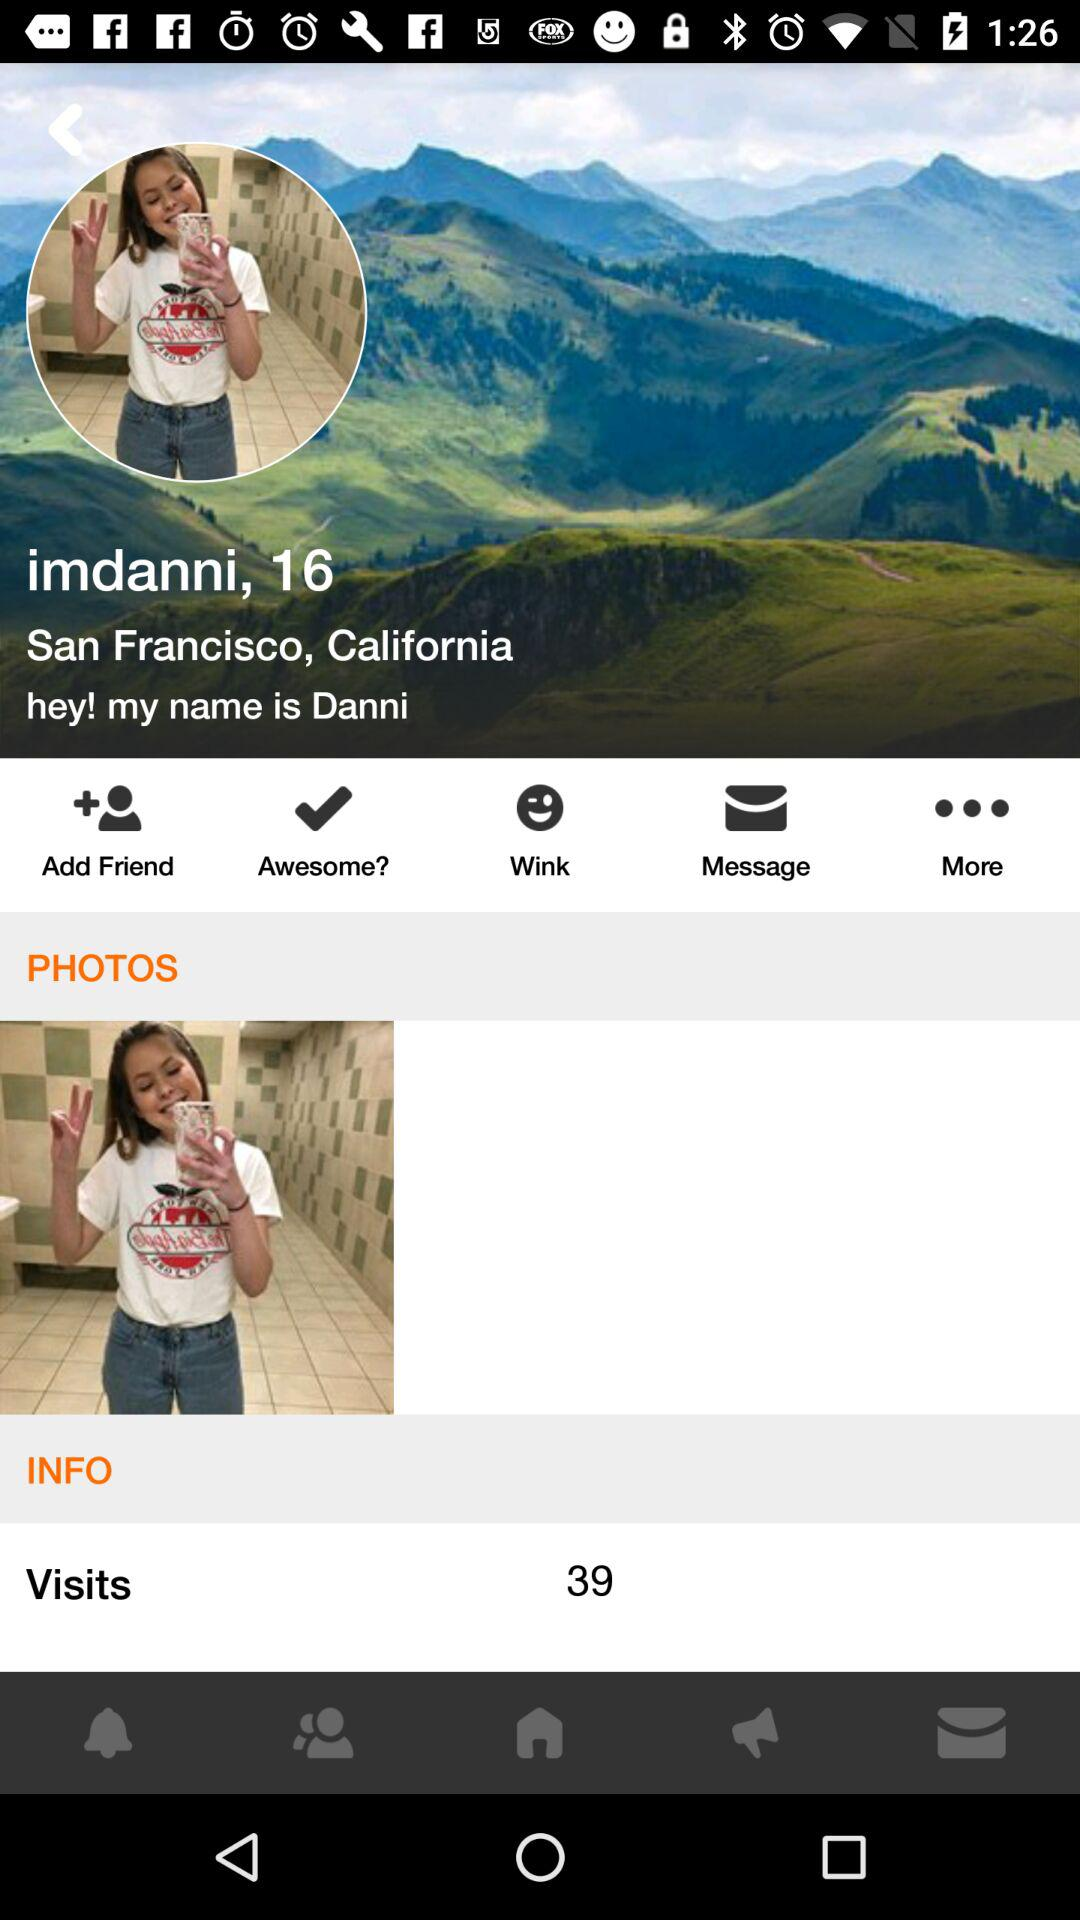How many visits in total are there? The number of visits is 39. 